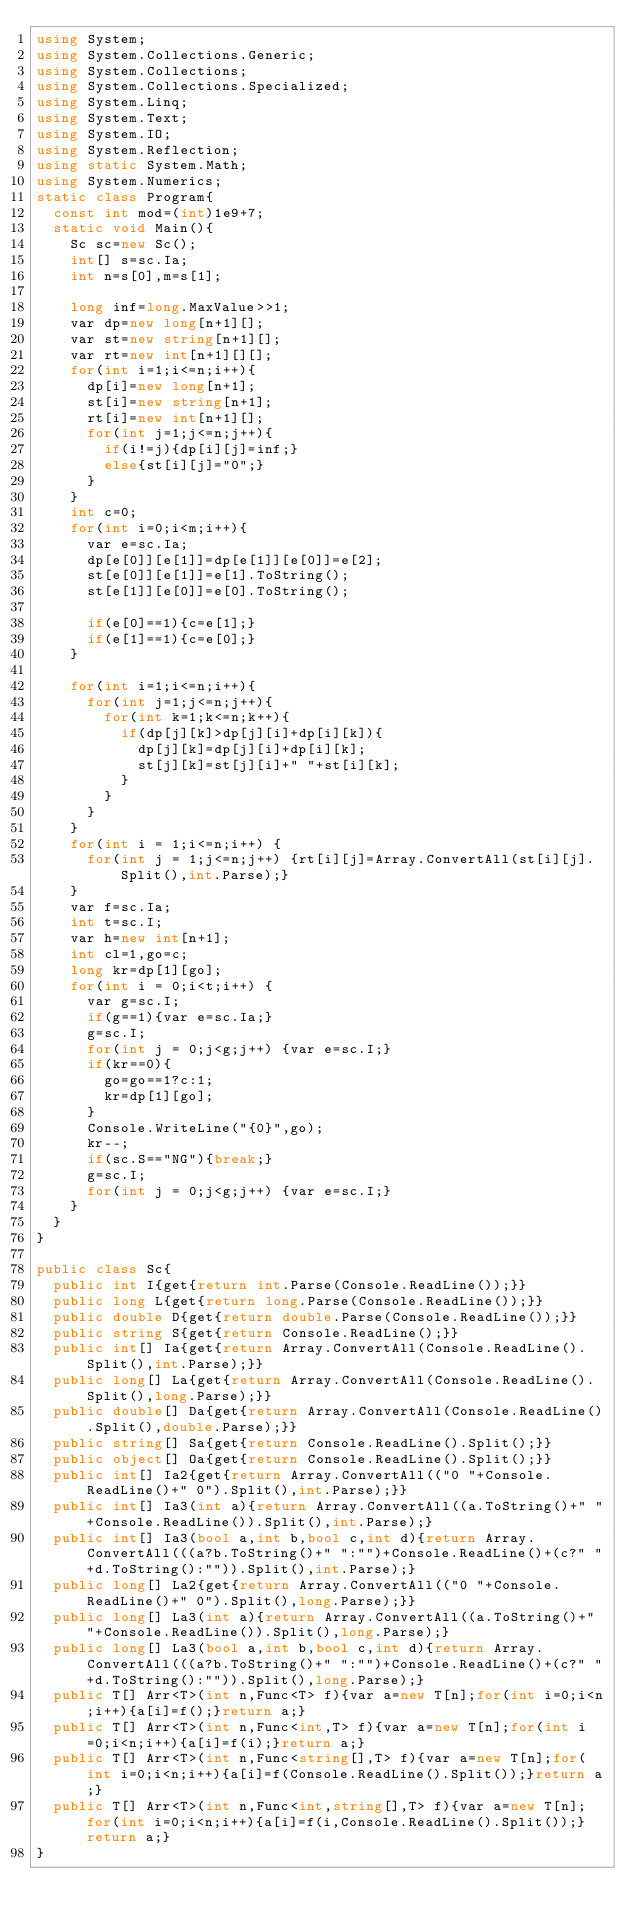<code> <loc_0><loc_0><loc_500><loc_500><_C#_>using System;
using System.Collections.Generic;
using System.Collections;
using System.Collections.Specialized;
using System.Linq;
using System.Text;
using System.IO;
using System.Reflection;
using static System.Math;
using System.Numerics;
static class Program{
	const int mod=(int)1e9+7;
	static void Main(){
		Sc sc=new Sc();
		int[] s=sc.Ia;
		int n=s[0],m=s[1];

		long inf=long.MaxValue>>1;
		var dp=new long[n+1][];
		var st=new string[n+1][];
		var rt=new int[n+1][][];
		for(int i=1;i<=n;i++){
			dp[i]=new long[n+1];
			st[i]=new string[n+1];
			rt[i]=new int[n+1][];
			for(int j=1;j<=n;j++){
				if(i!=j){dp[i][j]=inf;}
				else{st[i][j]="0";}
			}
		}
		int c=0;
		for(int i=0;i<m;i++){
			var e=sc.Ia;
			dp[e[0]][e[1]]=dp[e[1]][e[0]]=e[2];
			st[e[0]][e[1]]=e[1].ToString();
			st[e[1]][e[0]]=e[0].ToString();

			if(e[0]==1){c=e[1];}
			if(e[1]==1){c=e[0];}
		}

		for(int i=1;i<=n;i++){
			for(int j=1;j<=n;j++){
				for(int k=1;k<=n;k++){
					if(dp[j][k]>dp[j][i]+dp[i][k]){
						dp[j][k]=dp[j][i]+dp[i][k];
						st[j][k]=st[j][i]+" "+st[i][k];
					}
				}
			}
		}
		for(int i = 1;i<=n;i++) {
			for(int j = 1;j<=n;j++) {rt[i][j]=Array.ConvertAll(st[i][j].Split(),int.Parse);}
		}
		var f=sc.Ia;
		int t=sc.I;
		var h=new int[n+1];
		int cl=1,go=c;
		long kr=dp[1][go];
		for(int i = 0;i<t;i++) {
			var g=sc.I;
			if(g==1){var e=sc.Ia;}
			g=sc.I;
			for(int j = 0;j<g;j++) {var e=sc.I;}
			if(kr==0){
				go=go==1?c:1;
				kr=dp[1][go];
			}
			Console.WriteLine("{0}",go);
			kr--;
			if(sc.S=="NG"){break;}
			g=sc.I;
			for(int j = 0;j<g;j++) {var e=sc.I;}
		}
	}
}

public class Sc{
	public int I{get{return int.Parse(Console.ReadLine());}}
	public long L{get{return long.Parse(Console.ReadLine());}}
	public double D{get{return double.Parse(Console.ReadLine());}}
	public string S{get{return Console.ReadLine();}}
	public int[] Ia{get{return Array.ConvertAll(Console.ReadLine().Split(),int.Parse);}}
	public long[] La{get{return Array.ConvertAll(Console.ReadLine().Split(),long.Parse);}}
	public double[] Da{get{return Array.ConvertAll(Console.ReadLine().Split(),double.Parse);}}
	public string[] Sa{get{return Console.ReadLine().Split();}}
	public object[] Oa{get{return Console.ReadLine().Split();}}
	public int[] Ia2{get{return Array.ConvertAll(("0 "+Console.ReadLine()+" 0").Split(),int.Parse);}}
	public int[] Ia3(int a){return Array.ConvertAll((a.ToString()+" "+Console.ReadLine()).Split(),int.Parse);}
	public int[] Ia3(bool a,int b,bool c,int d){return Array.ConvertAll(((a?b.ToString()+" ":"")+Console.ReadLine()+(c?" "+d.ToString():"")).Split(),int.Parse);}
	public long[] La2{get{return Array.ConvertAll(("0 "+Console.ReadLine()+" 0").Split(),long.Parse);}}
	public long[] La3(int a){return Array.ConvertAll((a.ToString()+" "+Console.ReadLine()).Split(),long.Parse);}
	public long[] La3(bool a,int b,bool c,int d){return Array.ConvertAll(((a?b.ToString()+" ":"")+Console.ReadLine()+(c?" "+d.ToString():"")).Split(),long.Parse);}
	public T[] Arr<T>(int n,Func<T> f){var a=new T[n];for(int i=0;i<n;i++){a[i]=f();}return a;}
	public T[] Arr<T>(int n,Func<int,T> f){var a=new T[n];for(int i=0;i<n;i++){a[i]=f(i);}return a;}
	public T[] Arr<T>(int n,Func<string[],T> f){var a=new T[n];for(int i=0;i<n;i++){a[i]=f(Console.ReadLine().Split());}return a;}
	public T[] Arr<T>(int n,Func<int,string[],T> f){var a=new T[n];for(int i=0;i<n;i++){a[i]=f(i,Console.ReadLine().Split());}return a;}
}</code> 